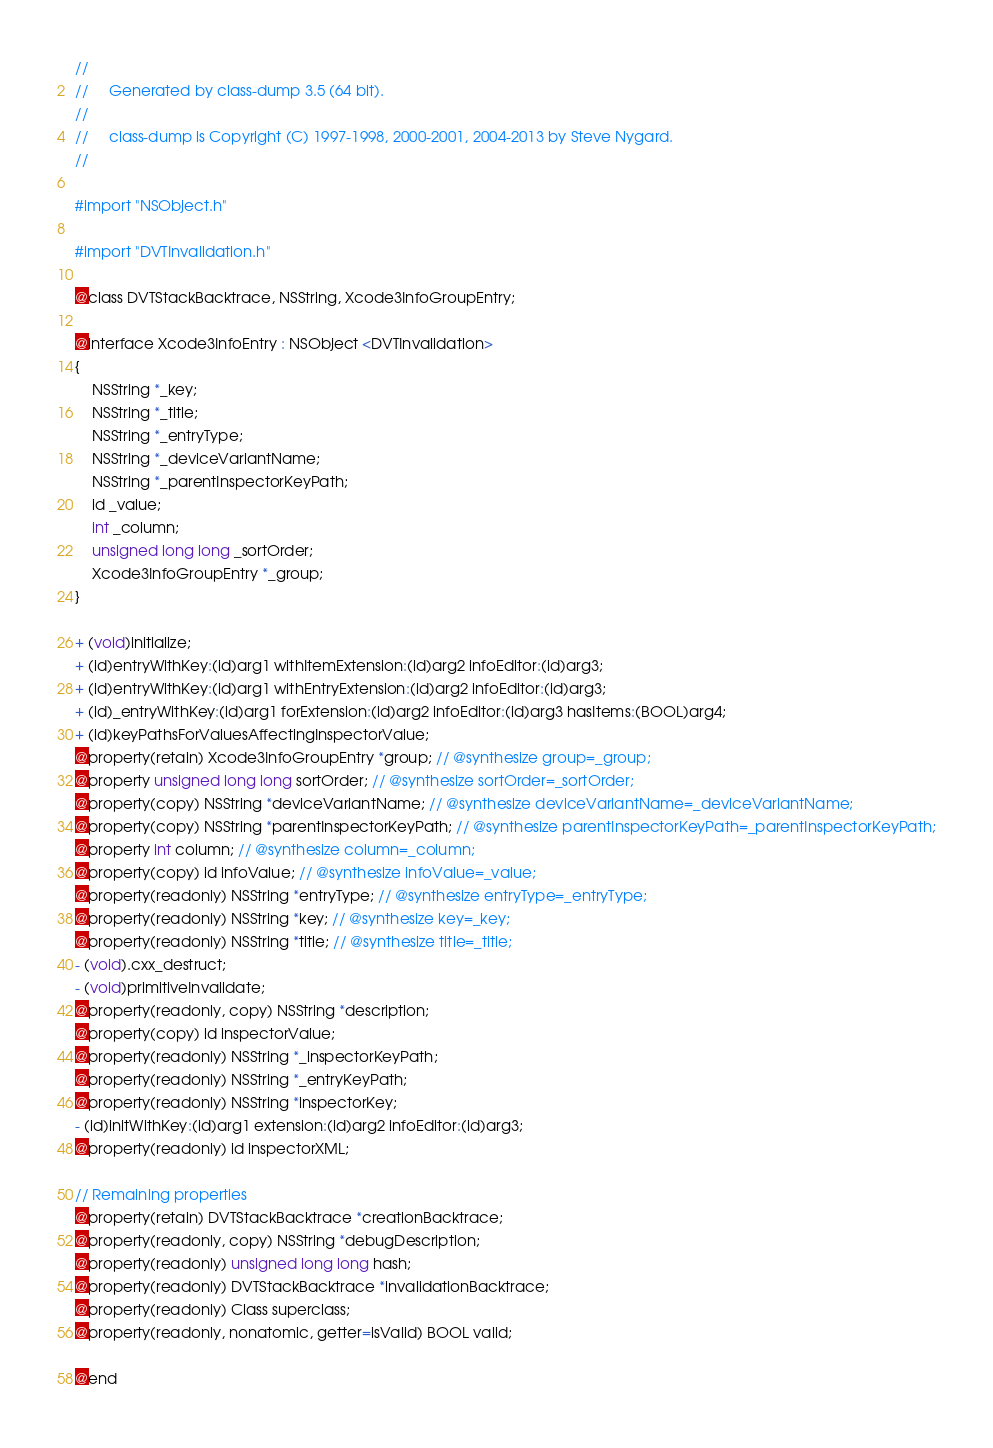Convert code to text. <code><loc_0><loc_0><loc_500><loc_500><_C_>//
//     Generated by class-dump 3.5 (64 bit).
//
//     class-dump is Copyright (C) 1997-1998, 2000-2001, 2004-2013 by Steve Nygard.
//

#import "NSObject.h"

#import "DVTInvalidation.h"

@class DVTStackBacktrace, NSString, Xcode3InfoGroupEntry;

@interface Xcode3InfoEntry : NSObject <DVTInvalidation>
{
    NSString *_key;
    NSString *_title;
    NSString *_entryType;
    NSString *_deviceVariantName;
    NSString *_parentInspectorKeyPath;
    id _value;
    int _column;
    unsigned long long _sortOrder;
    Xcode3InfoGroupEntry *_group;
}

+ (void)initialize;
+ (id)entryWithKey:(id)arg1 withItemExtension:(id)arg2 infoEditor:(id)arg3;
+ (id)entryWithKey:(id)arg1 withEntryExtension:(id)arg2 infoEditor:(id)arg3;
+ (id)_entryWithKey:(id)arg1 forExtension:(id)arg2 infoEditor:(id)arg3 hasItems:(BOOL)arg4;
+ (id)keyPathsForValuesAffectingInspectorValue;
@property(retain) Xcode3InfoGroupEntry *group; // @synthesize group=_group;
@property unsigned long long sortOrder; // @synthesize sortOrder=_sortOrder;
@property(copy) NSString *deviceVariantName; // @synthesize deviceVariantName=_deviceVariantName;
@property(copy) NSString *parentInspectorKeyPath; // @synthesize parentInspectorKeyPath=_parentInspectorKeyPath;
@property int column; // @synthesize column=_column;
@property(copy) id infoValue; // @synthesize infoValue=_value;
@property(readonly) NSString *entryType; // @synthesize entryType=_entryType;
@property(readonly) NSString *key; // @synthesize key=_key;
@property(readonly) NSString *title; // @synthesize title=_title;
- (void).cxx_destruct;
- (void)primitiveInvalidate;
@property(readonly, copy) NSString *description;
@property(copy) id inspectorValue;
@property(readonly) NSString *_inspectorKeyPath;
@property(readonly) NSString *_entryKeyPath;
@property(readonly) NSString *inspectorKey;
- (id)initWithKey:(id)arg1 extension:(id)arg2 infoEditor:(id)arg3;
@property(readonly) id inspectorXML;

// Remaining properties
@property(retain) DVTStackBacktrace *creationBacktrace;
@property(readonly, copy) NSString *debugDescription;
@property(readonly) unsigned long long hash;
@property(readonly) DVTStackBacktrace *invalidationBacktrace;
@property(readonly) Class superclass;
@property(readonly, nonatomic, getter=isValid) BOOL valid;

@end

</code> 